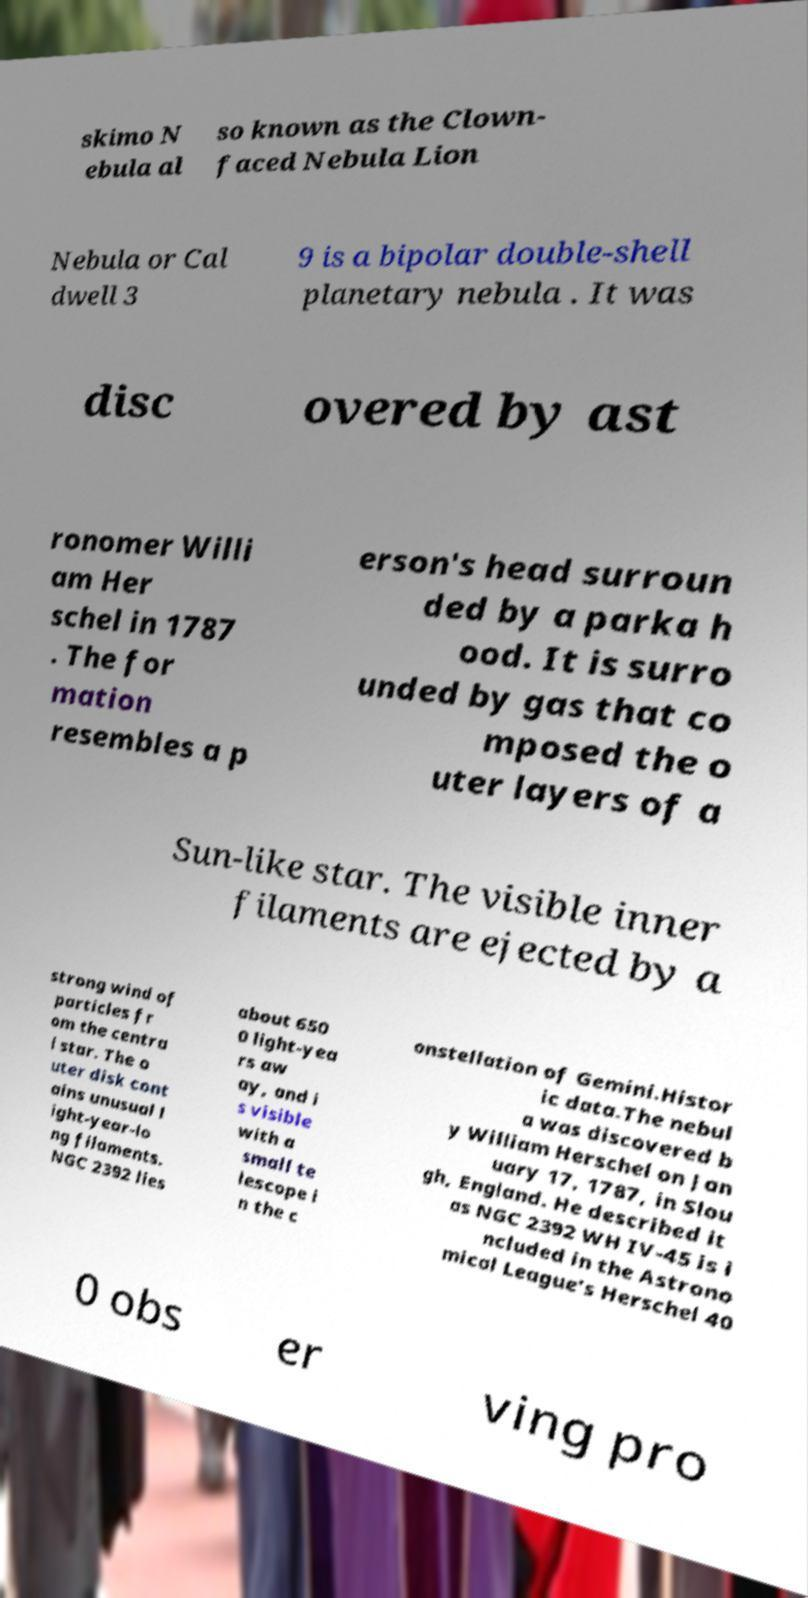Can you read and provide the text displayed in the image?This photo seems to have some interesting text. Can you extract and type it out for me? skimo N ebula al so known as the Clown- faced Nebula Lion Nebula or Cal dwell 3 9 is a bipolar double-shell planetary nebula . It was disc overed by ast ronomer Willi am Her schel in 1787 . The for mation resembles a p erson's head surroun ded by a parka h ood. It is surro unded by gas that co mposed the o uter layers of a Sun-like star. The visible inner filaments are ejected by a strong wind of particles fr om the centra l star. The o uter disk cont ains unusual l ight-year-lo ng filaments. NGC 2392 lies about 650 0 light-yea rs aw ay, and i s visible with a small te lescope i n the c onstellation of Gemini.Histor ic data.The nebul a was discovered b y William Herschel on Jan uary 17, 1787, in Slou gh, England. He described it as NGC 2392 WH IV-45 is i ncluded in the Astrono mical League's Herschel 40 0 obs er ving pro 